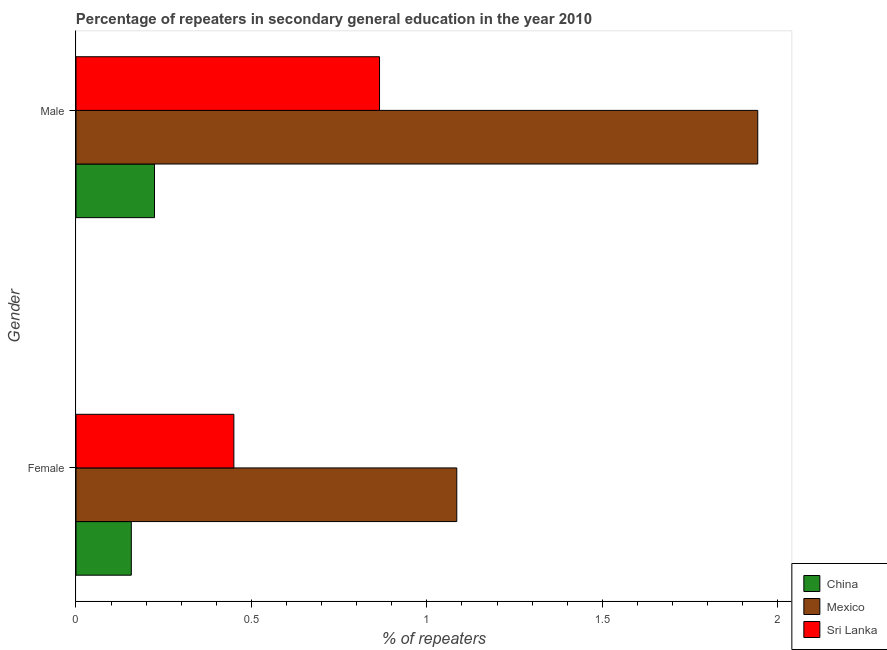How many different coloured bars are there?
Provide a succinct answer. 3. What is the percentage of male repeaters in Mexico?
Keep it short and to the point. 1.94. Across all countries, what is the maximum percentage of male repeaters?
Give a very brief answer. 1.94. Across all countries, what is the minimum percentage of female repeaters?
Offer a very short reply. 0.16. In which country was the percentage of female repeaters minimum?
Give a very brief answer. China. What is the total percentage of male repeaters in the graph?
Ensure brevity in your answer.  3.03. What is the difference between the percentage of male repeaters in China and that in Mexico?
Offer a very short reply. -1.72. What is the difference between the percentage of male repeaters in Sri Lanka and the percentage of female repeaters in China?
Give a very brief answer. 0.71. What is the average percentage of female repeaters per country?
Your response must be concise. 0.56. What is the difference between the percentage of female repeaters and percentage of male repeaters in China?
Offer a very short reply. -0.07. In how many countries, is the percentage of female repeaters greater than 1.4 %?
Offer a terse response. 0. What is the ratio of the percentage of male repeaters in Mexico to that in Sri Lanka?
Keep it short and to the point. 2.25. Is the percentage of male repeaters in China less than that in Mexico?
Ensure brevity in your answer.  Yes. What does the 1st bar from the top in Female represents?
Your answer should be very brief. Sri Lanka. How many bars are there?
Provide a succinct answer. 6. What is the difference between two consecutive major ticks on the X-axis?
Give a very brief answer. 0.5. How many legend labels are there?
Your answer should be very brief. 3. How are the legend labels stacked?
Keep it short and to the point. Vertical. What is the title of the graph?
Your answer should be compact. Percentage of repeaters in secondary general education in the year 2010. Does "St. Vincent and the Grenadines" appear as one of the legend labels in the graph?
Make the answer very short. No. What is the label or title of the X-axis?
Provide a short and direct response. % of repeaters. What is the % of repeaters of China in Female?
Make the answer very short. 0.16. What is the % of repeaters of Mexico in Female?
Offer a very short reply. 1.09. What is the % of repeaters of Sri Lanka in Female?
Provide a succinct answer. 0.45. What is the % of repeaters in China in Male?
Provide a succinct answer. 0.22. What is the % of repeaters of Mexico in Male?
Your answer should be very brief. 1.94. What is the % of repeaters in Sri Lanka in Male?
Your answer should be very brief. 0.87. Across all Gender, what is the maximum % of repeaters in China?
Give a very brief answer. 0.22. Across all Gender, what is the maximum % of repeaters of Mexico?
Keep it short and to the point. 1.94. Across all Gender, what is the maximum % of repeaters in Sri Lanka?
Ensure brevity in your answer.  0.87. Across all Gender, what is the minimum % of repeaters of China?
Your answer should be compact. 0.16. Across all Gender, what is the minimum % of repeaters of Mexico?
Your response must be concise. 1.09. Across all Gender, what is the minimum % of repeaters in Sri Lanka?
Your answer should be very brief. 0.45. What is the total % of repeaters in China in the graph?
Offer a terse response. 0.38. What is the total % of repeaters in Mexico in the graph?
Ensure brevity in your answer.  3.03. What is the total % of repeaters in Sri Lanka in the graph?
Your response must be concise. 1.32. What is the difference between the % of repeaters of China in Female and that in Male?
Give a very brief answer. -0.07. What is the difference between the % of repeaters of Mexico in Female and that in Male?
Keep it short and to the point. -0.86. What is the difference between the % of repeaters in Sri Lanka in Female and that in Male?
Provide a short and direct response. -0.42. What is the difference between the % of repeaters of China in Female and the % of repeaters of Mexico in Male?
Your answer should be very brief. -1.79. What is the difference between the % of repeaters in China in Female and the % of repeaters in Sri Lanka in Male?
Provide a short and direct response. -0.71. What is the difference between the % of repeaters of Mexico in Female and the % of repeaters of Sri Lanka in Male?
Offer a very short reply. 0.22. What is the average % of repeaters in China per Gender?
Provide a succinct answer. 0.19. What is the average % of repeaters of Mexico per Gender?
Keep it short and to the point. 1.51. What is the average % of repeaters of Sri Lanka per Gender?
Ensure brevity in your answer.  0.66. What is the difference between the % of repeaters of China and % of repeaters of Mexico in Female?
Provide a succinct answer. -0.93. What is the difference between the % of repeaters in China and % of repeaters in Sri Lanka in Female?
Provide a succinct answer. -0.29. What is the difference between the % of repeaters of Mexico and % of repeaters of Sri Lanka in Female?
Give a very brief answer. 0.64. What is the difference between the % of repeaters of China and % of repeaters of Mexico in Male?
Give a very brief answer. -1.72. What is the difference between the % of repeaters of China and % of repeaters of Sri Lanka in Male?
Ensure brevity in your answer.  -0.64. What is the difference between the % of repeaters of Mexico and % of repeaters of Sri Lanka in Male?
Make the answer very short. 1.08. What is the ratio of the % of repeaters in China in Female to that in Male?
Provide a short and direct response. 0.7. What is the ratio of the % of repeaters of Mexico in Female to that in Male?
Give a very brief answer. 0.56. What is the ratio of the % of repeaters in Sri Lanka in Female to that in Male?
Provide a short and direct response. 0.52. What is the difference between the highest and the second highest % of repeaters of China?
Make the answer very short. 0.07. What is the difference between the highest and the second highest % of repeaters of Mexico?
Your answer should be compact. 0.86. What is the difference between the highest and the second highest % of repeaters of Sri Lanka?
Offer a very short reply. 0.42. What is the difference between the highest and the lowest % of repeaters of China?
Your response must be concise. 0.07. What is the difference between the highest and the lowest % of repeaters of Mexico?
Your response must be concise. 0.86. What is the difference between the highest and the lowest % of repeaters in Sri Lanka?
Make the answer very short. 0.42. 